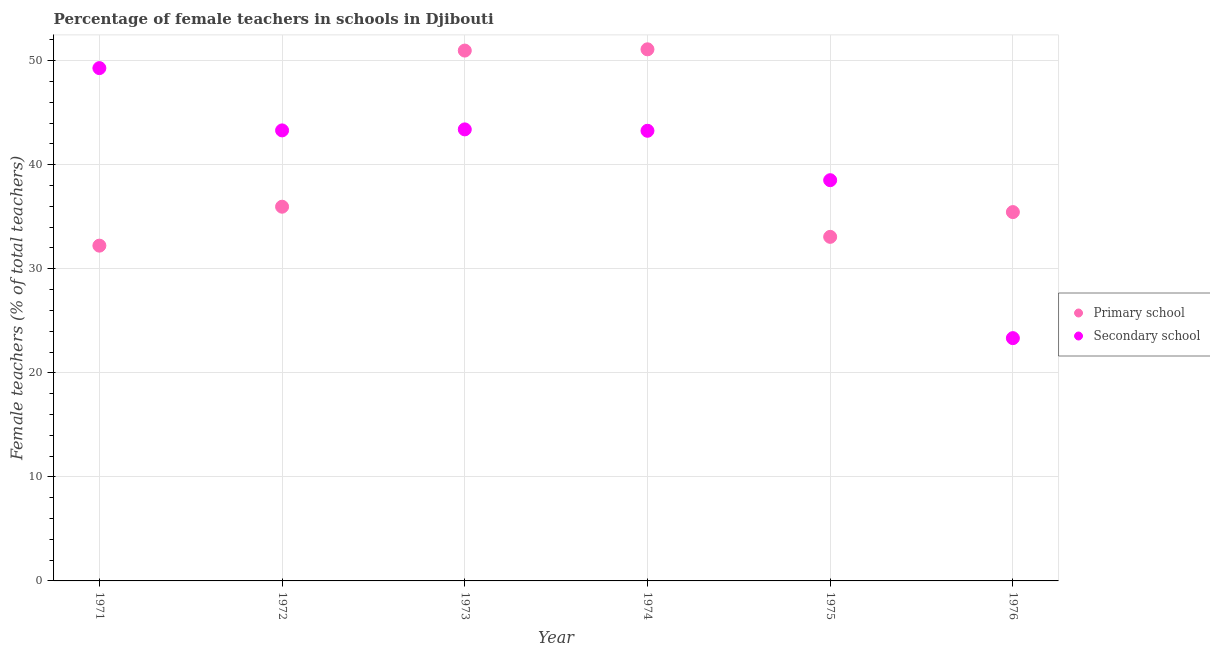How many different coloured dotlines are there?
Provide a succinct answer. 2. What is the percentage of female teachers in primary schools in 1972?
Give a very brief answer. 35.96. Across all years, what is the maximum percentage of female teachers in secondary schools?
Your answer should be compact. 49.29. Across all years, what is the minimum percentage of female teachers in primary schools?
Ensure brevity in your answer.  32.22. In which year was the percentage of female teachers in secondary schools maximum?
Provide a short and direct response. 1971. In which year was the percentage of female teachers in secondary schools minimum?
Your response must be concise. 1976. What is the total percentage of female teachers in secondary schools in the graph?
Provide a succinct answer. 241.09. What is the difference between the percentage of female teachers in primary schools in 1971 and that in 1974?
Provide a succinct answer. -18.87. What is the difference between the percentage of female teachers in secondary schools in 1975 and the percentage of female teachers in primary schools in 1972?
Offer a terse response. 2.55. What is the average percentage of female teachers in secondary schools per year?
Offer a very short reply. 40.18. In the year 1975, what is the difference between the percentage of female teachers in secondary schools and percentage of female teachers in primary schools?
Make the answer very short. 5.45. What is the ratio of the percentage of female teachers in secondary schools in 1971 to that in 1975?
Offer a very short reply. 1.28. What is the difference between the highest and the second highest percentage of female teachers in primary schools?
Make the answer very short. 0.12. What is the difference between the highest and the lowest percentage of female teachers in secondary schools?
Ensure brevity in your answer.  25.95. How many years are there in the graph?
Provide a succinct answer. 6. What is the difference between two consecutive major ticks on the Y-axis?
Ensure brevity in your answer.  10. Are the values on the major ticks of Y-axis written in scientific E-notation?
Your response must be concise. No. Where does the legend appear in the graph?
Offer a terse response. Center right. How many legend labels are there?
Ensure brevity in your answer.  2. What is the title of the graph?
Give a very brief answer. Percentage of female teachers in schools in Djibouti. Does "Female population" appear as one of the legend labels in the graph?
Your answer should be very brief. No. What is the label or title of the Y-axis?
Offer a terse response. Female teachers (% of total teachers). What is the Female teachers (% of total teachers) of Primary school in 1971?
Your answer should be compact. 32.22. What is the Female teachers (% of total teachers) in Secondary school in 1971?
Ensure brevity in your answer.  49.29. What is the Female teachers (% of total teachers) in Primary school in 1972?
Give a very brief answer. 35.96. What is the Female teachers (% of total teachers) in Secondary school in 1972?
Give a very brief answer. 43.3. What is the Female teachers (% of total teachers) in Primary school in 1973?
Keep it short and to the point. 50.97. What is the Female teachers (% of total teachers) in Secondary school in 1973?
Give a very brief answer. 43.4. What is the Female teachers (% of total teachers) of Primary school in 1974?
Offer a terse response. 51.09. What is the Female teachers (% of total teachers) in Secondary school in 1974?
Make the answer very short. 43.26. What is the Female teachers (% of total teachers) in Primary school in 1975?
Keep it short and to the point. 33.07. What is the Female teachers (% of total teachers) of Secondary school in 1975?
Offer a terse response. 38.51. What is the Female teachers (% of total teachers) of Primary school in 1976?
Make the answer very short. 35.45. What is the Female teachers (% of total teachers) of Secondary school in 1976?
Offer a terse response. 23.33. Across all years, what is the maximum Female teachers (% of total teachers) of Primary school?
Ensure brevity in your answer.  51.09. Across all years, what is the maximum Female teachers (% of total teachers) of Secondary school?
Keep it short and to the point. 49.29. Across all years, what is the minimum Female teachers (% of total teachers) of Primary school?
Your answer should be very brief. 32.22. Across all years, what is the minimum Female teachers (% of total teachers) in Secondary school?
Give a very brief answer. 23.33. What is the total Female teachers (% of total teachers) of Primary school in the graph?
Offer a very short reply. 238.77. What is the total Female teachers (% of total teachers) of Secondary school in the graph?
Make the answer very short. 241.09. What is the difference between the Female teachers (% of total teachers) in Primary school in 1971 and that in 1972?
Your answer should be very brief. -3.74. What is the difference between the Female teachers (% of total teachers) in Secondary school in 1971 and that in 1972?
Give a very brief answer. 5.99. What is the difference between the Female teachers (% of total teachers) in Primary school in 1971 and that in 1973?
Your response must be concise. -18.75. What is the difference between the Female teachers (% of total teachers) of Secondary school in 1971 and that in 1973?
Keep it short and to the point. 5.89. What is the difference between the Female teachers (% of total teachers) of Primary school in 1971 and that in 1974?
Keep it short and to the point. -18.87. What is the difference between the Female teachers (% of total teachers) in Secondary school in 1971 and that in 1974?
Keep it short and to the point. 6.02. What is the difference between the Female teachers (% of total teachers) of Primary school in 1971 and that in 1975?
Keep it short and to the point. -0.85. What is the difference between the Female teachers (% of total teachers) in Secondary school in 1971 and that in 1975?
Make the answer very short. 10.77. What is the difference between the Female teachers (% of total teachers) in Primary school in 1971 and that in 1976?
Offer a very short reply. -3.23. What is the difference between the Female teachers (% of total teachers) in Secondary school in 1971 and that in 1976?
Your answer should be compact. 25.95. What is the difference between the Female teachers (% of total teachers) in Primary school in 1972 and that in 1973?
Give a very brief answer. -15.01. What is the difference between the Female teachers (% of total teachers) of Secondary school in 1972 and that in 1973?
Keep it short and to the point. -0.1. What is the difference between the Female teachers (% of total teachers) in Primary school in 1972 and that in 1974?
Offer a terse response. -15.13. What is the difference between the Female teachers (% of total teachers) in Secondary school in 1972 and that in 1974?
Offer a very short reply. 0.04. What is the difference between the Female teachers (% of total teachers) of Primary school in 1972 and that in 1975?
Your answer should be compact. 2.9. What is the difference between the Female teachers (% of total teachers) of Secondary school in 1972 and that in 1975?
Your answer should be very brief. 4.79. What is the difference between the Female teachers (% of total teachers) in Primary school in 1972 and that in 1976?
Keep it short and to the point. 0.52. What is the difference between the Female teachers (% of total teachers) in Secondary school in 1972 and that in 1976?
Ensure brevity in your answer.  19.97. What is the difference between the Female teachers (% of total teachers) of Primary school in 1973 and that in 1974?
Keep it short and to the point. -0.12. What is the difference between the Female teachers (% of total teachers) in Secondary school in 1973 and that in 1974?
Give a very brief answer. 0.13. What is the difference between the Female teachers (% of total teachers) in Primary school in 1973 and that in 1975?
Provide a succinct answer. 17.9. What is the difference between the Female teachers (% of total teachers) of Secondary school in 1973 and that in 1975?
Your answer should be compact. 4.88. What is the difference between the Female teachers (% of total teachers) of Primary school in 1973 and that in 1976?
Your response must be concise. 15.52. What is the difference between the Female teachers (% of total teachers) of Secondary school in 1973 and that in 1976?
Your answer should be compact. 20.06. What is the difference between the Female teachers (% of total teachers) of Primary school in 1974 and that in 1975?
Ensure brevity in your answer.  18.02. What is the difference between the Female teachers (% of total teachers) in Secondary school in 1974 and that in 1975?
Your answer should be compact. 4.75. What is the difference between the Female teachers (% of total teachers) of Primary school in 1974 and that in 1976?
Offer a very short reply. 15.64. What is the difference between the Female teachers (% of total teachers) of Secondary school in 1974 and that in 1976?
Your answer should be very brief. 19.93. What is the difference between the Female teachers (% of total teachers) in Primary school in 1975 and that in 1976?
Make the answer very short. -2.38. What is the difference between the Female teachers (% of total teachers) in Secondary school in 1975 and that in 1976?
Ensure brevity in your answer.  15.18. What is the difference between the Female teachers (% of total teachers) in Primary school in 1971 and the Female teachers (% of total teachers) in Secondary school in 1972?
Offer a terse response. -11.08. What is the difference between the Female teachers (% of total teachers) of Primary school in 1971 and the Female teachers (% of total teachers) of Secondary school in 1973?
Offer a terse response. -11.17. What is the difference between the Female teachers (% of total teachers) of Primary school in 1971 and the Female teachers (% of total teachers) of Secondary school in 1974?
Ensure brevity in your answer.  -11.04. What is the difference between the Female teachers (% of total teachers) of Primary school in 1971 and the Female teachers (% of total teachers) of Secondary school in 1975?
Keep it short and to the point. -6.29. What is the difference between the Female teachers (% of total teachers) of Primary school in 1971 and the Female teachers (% of total teachers) of Secondary school in 1976?
Keep it short and to the point. 8.89. What is the difference between the Female teachers (% of total teachers) of Primary school in 1972 and the Female teachers (% of total teachers) of Secondary school in 1973?
Offer a terse response. -7.43. What is the difference between the Female teachers (% of total teachers) of Primary school in 1972 and the Female teachers (% of total teachers) of Secondary school in 1974?
Keep it short and to the point. -7.3. What is the difference between the Female teachers (% of total teachers) of Primary school in 1972 and the Female teachers (% of total teachers) of Secondary school in 1975?
Your response must be concise. -2.55. What is the difference between the Female teachers (% of total teachers) in Primary school in 1972 and the Female teachers (% of total teachers) in Secondary school in 1976?
Your answer should be compact. 12.63. What is the difference between the Female teachers (% of total teachers) in Primary school in 1973 and the Female teachers (% of total teachers) in Secondary school in 1974?
Offer a very short reply. 7.71. What is the difference between the Female teachers (% of total teachers) of Primary school in 1973 and the Female teachers (% of total teachers) of Secondary school in 1975?
Your response must be concise. 12.46. What is the difference between the Female teachers (% of total teachers) of Primary school in 1973 and the Female teachers (% of total teachers) of Secondary school in 1976?
Your response must be concise. 27.64. What is the difference between the Female teachers (% of total teachers) in Primary school in 1974 and the Female teachers (% of total teachers) in Secondary school in 1975?
Your response must be concise. 12.58. What is the difference between the Female teachers (% of total teachers) in Primary school in 1974 and the Female teachers (% of total teachers) in Secondary school in 1976?
Make the answer very short. 27.76. What is the difference between the Female teachers (% of total teachers) of Primary school in 1975 and the Female teachers (% of total teachers) of Secondary school in 1976?
Offer a very short reply. 9.73. What is the average Female teachers (% of total teachers) in Primary school per year?
Offer a very short reply. 39.79. What is the average Female teachers (% of total teachers) of Secondary school per year?
Your response must be concise. 40.18. In the year 1971, what is the difference between the Female teachers (% of total teachers) in Primary school and Female teachers (% of total teachers) in Secondary school?
Keep it short and to the point. -17.06. In the year 1972, what is the difference between the Female teachers (% of total teachers) in Primary school and Female teachers (% of total teachers) in Secondary school?
Your answer should be compact. -7.33. In the year 1973, what is the difference between the Female teachers (% of total teachers) in Primary school and Female teachers (% of total teachers) in Secondary school?
Your response must be concise. 7.57. In the year 1974, what is the difference between the Female teachers (% of total teachers) of Primary school and Female teachers (% of total teachers) of Secondary school?
Keep it short and to the point. 7.83. In the year 1975, what is the difference between the Female teachers (% of total teachers) in Primary school and Female teachers (% of total teachers) in Secondary school?
Your answer should be very brief. -5.45. In the year 1976, what is the difference between the Female teachers (% of total teachers) of Primary school and Female teachers (% of total teachers) of Secondary school?
Your answer should be compact. 12.11. What is the ratio of the Female teachers (% of total teachers) of Primary school in 1971 to that in 1972?
Ensure brevity in your answer.  0.9. What is the ratio of the Female teachers (% of total teachers) of Secondary school in 1971 to that in 1972?
Keep it short and to the point. 1.14. What is the ratio of the Female teachers (% of total teachers) of Primary school in 1971 to that in 1973?
Keep it short and to the point. 0.63. What is the ratio of the Female teachers (% of total teachers) of Secondary school in 1971 to that in 1973?
Ensure brevity in your answer.  1.14. What is the ratio of the Female teachers (% of total teachers) of Primary school in 1971 to that in 1974?
Your answer should be very brief. 0.63. What is the ratio of the Female teachers (% of total teachers) of Secondary school in 1971 to that in 1974?
Provide a short and direct response. 1.14. What is the ratio of the Female teachers (% of total teachers) in Primary school in 1971 to that in 1975?
Provide a short and direct response. 0.97. What is the ratio of the Female teachers (% of total teachers) in Secondary school in 1971 to that in 1975?
Your answer should be very brief. 1.28. What is the ratio of the Female teachers (% of total teachers) in Primary school in 1971 to that in 1976?
Ensure brevity in your answer.  0.91. What is the ratio of the Female teachers (% of total teachers) of Secondary school in 1971 to that in 1976?
Offer a very short reply. 2.11. What is the ratio of the Female teachers (% of total teachers) of Primary school in 1972 to that in 1973?
Your answer should be compact. 0.71. What is the ratio of the Female teachers (% of total teachers) of Secondary school in 1972 to that in 1973?
Give a very brief answer. 1. What is the ratio of the Female teachers (% of total teachers) of Primary school in 1972 to that in 1974?
Your answer should be compact. 0.7. What is the ratio of the Female teachers (% of total teachers) of Secondary school in 1972 to that in 1974?
Keep it short and to the point. 1. What is the ratio of the Female teachers (% of total teachers) of Primary school in 1972 to that in 1975?
Make the answer very short. 1.09. What is the ratio of the Female teachers (% of total teachers) in Secondary school in 1972 to that in 1975?
Your answer should be very brief. 1.12. What is the ratio of the Female teachers (% of total teachers) in Primary school in 1972 to that in 1976?
Make the answer very short. 1.01. What is the ratio of the Female teachers (% of total teachers) of Secondary school in 1972 to that in 1976?
Your answer should be compact. 1.86. What is the ratio of the Female teachers (% of total teachers) of Primary school in 1973 to that in 1974?
Make the answer very short. 1. What is the ratio of the Female teachers (% of total teachers) in Primary school in 1973 to that in 1975?
Make the answer very short. 1.54. What is the ratio of the Female teachers (% of total teachers) in Secondary school in 1973 to that in 1975?
Offer a very short reply. 1.13. What is the ratio of the Female teachers (% of total teachers) in Primary school in 1973 to that in 1976?
Give a very brief answer. 1.44. What is the ratio of the Female teachers (% of total teachers) in Secondary school in 1973 to that in 1976?
Your answer should be very brief. 1.86. What is the ratio of the Female teachers (% of total teachers) of Primary school in 1974 to that in 1975?
Provide a short and direct response. 1.55. What is the ratio of the Female teachers (% of total teachers) of Secondary school in 1974 to that in 1975?
Keep it short and to the point. 1.12. What is the ratio of the Female teachers (% of total teachers) of Primary school in 1974 to that in 1976?
Your response must be concise. 1.44. What is the ratio of the Female teachers (% of total teachers) of Secondary school in 1974 to that in 1976?
Your answer should be compact. 1.85. What is the ratio of the Female teachers (% of total teachers) in Primary school in 1975 to that in 1976?
Keep it short and to the point. 0.93. What is the ratio of the Female teachers (% of total teachers) of Secondary school in 1975 to that in 1976?
Your answer should be compact. 1.65. What is the difference between the highest and the second highest Female teachers (% of total teachers) in Primary school?
Your response must be concise. 0.12. What is the difference between the highest and the second highest Female teachers (% of total teachers) of Secondary school?
Make the answer very short. 5.89. What is the difference between the highest and the lowest Female teachers (% of total teachers) in Primary school?
Make the answer very short. 18.87. What is the difference between the highest and the lowest Female teachers (% of total teachers) of Secondary school?
Offer a very short reply. 25.95. 